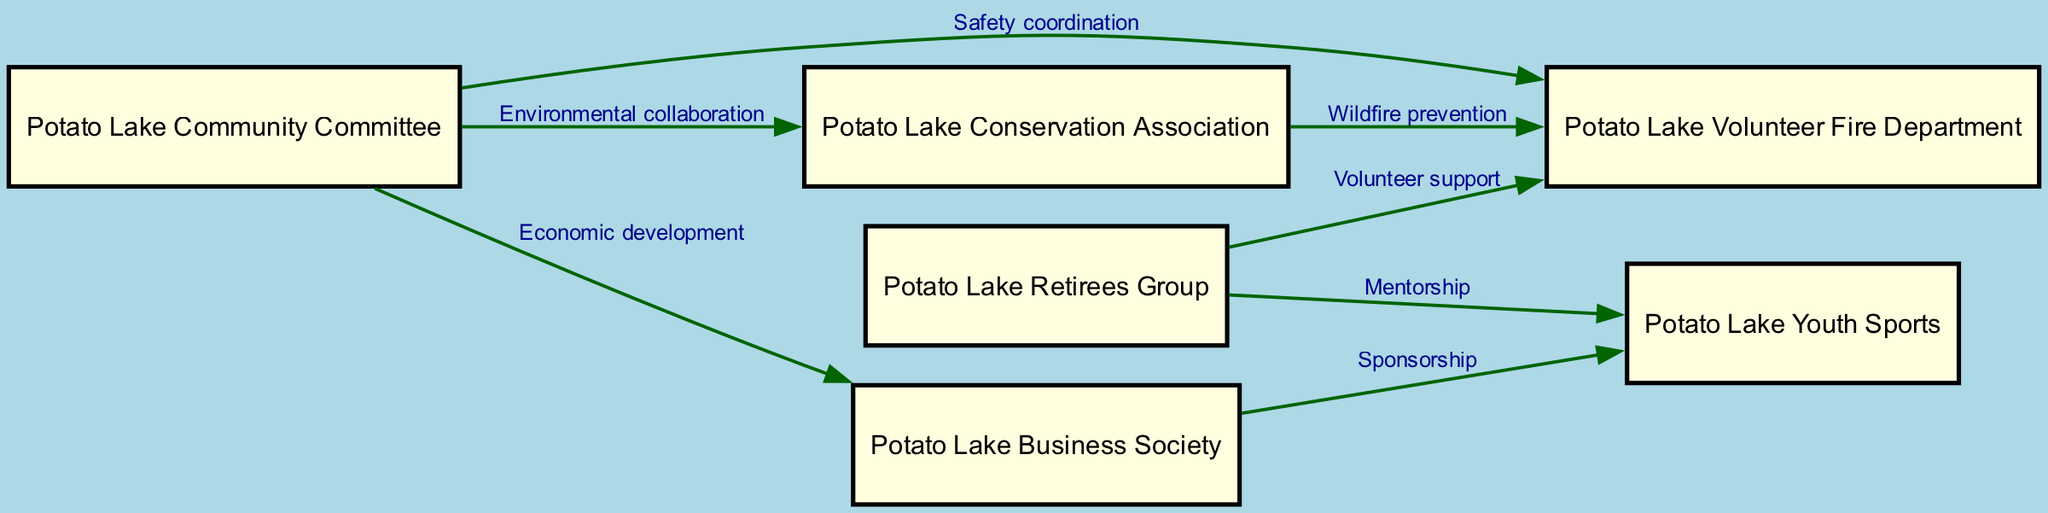What is the total number of nodes in the diagram? The diagram lists several organizations as nodes. We count the number of entries under 'nodes', which totals to six distinct organizations: Potato Lake Community Committee, Potato Lake Conservation Association, Potato Lake Business Society, Potato Lake Volunteer Fire Department, Potato Lake Retirees Group, and Potato Lake Youth Sports.
Answer: 6 Which organization has a connection for economic development? The edge labeled "Economic development" directly connects the Potato Lake Community Committee to the Potato Lake Business Society. By identifying the labeled edge and its endpoints, we can determine that the Potato Lake Business Society is involved in this connection.
Answer: Potato Lake Business Society How many edges are connecting the Potato Lake Volunteer Fire Department? To find the number of edges connected to the Potato Lake Volunteer Fire Department, we need to count the edges that originate from or point to this node. There are three edges: one from the Potato Lake Community Committee, one from the Potato Lake Conservation Association, and one from the Potato Lake Retirees Group. Therefore, the total count is three.
Answer: 3 What type of collaboration exists between the Potato Lake Community Committee and the Potato Lake Conservation Association? The diagram specifies the relationship between these two organizations as "Environmental collaboration". By locating the edge that connects these two nodes and reading its label, we reveal the nature of their collaboration.
Answer: Environmental collaboration Which organization provides mentorship to the Potato Lake Youth Sports? According to the diagram, the Potato Lake Retirees Group has a mentorship relationship with the Potato Lake Youth Sports. This connection is identified through the edge labeled "Mentorship" pointing to the Potato Lake Youth Sports from the Potato Lake Retirees Group.
Answer: Potato Lake Retirees Group What is the relationship labeled for the connection between the Potato Lake Conservation Association and the Potato Lake Volunteer Fire Department? The connection between the Potato Lake Conservation Association and the Potato Lake Volunteer Fire Department is labeled "Wildfire prevention". Inspecting the edge that links these two nodes reveals this specific relationship.
Answer: Wildfire prevention 